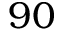Convert formula to latex. <formula><loc_0><loc_0><loc_500><loc_500>9 0</formula> 